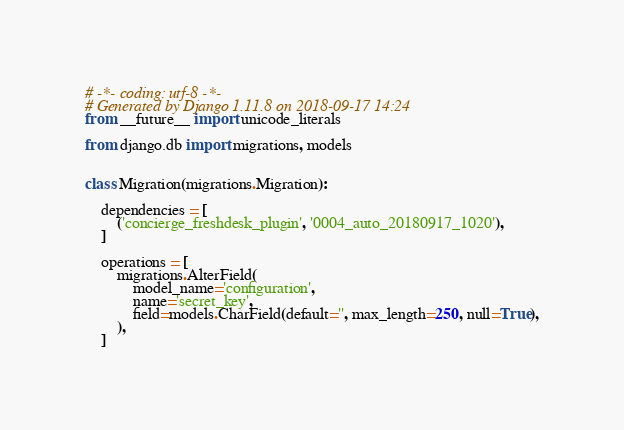Convert code to text. <code><loc_0><loc_0><loc_500><loc_500><_Python_># -*- coding: utf-8 -*-
# Generated by Django 1.11.8 on 2018-09-17 14:24
from __future__ import unicode_literals

from django.db import migrations, models


class Migration(migrations.Migration):

    dependencies = [
        ('concierge_freshdesk_plugin', '0004_auto_20180917_1020'),
    ]

    operations = [
        migrations.AlterField(
            model_name='configuration',
            name='secret_key',
            field=models.CharField(default='', max_length=250, null=True),
        ),
    ]
</code> 